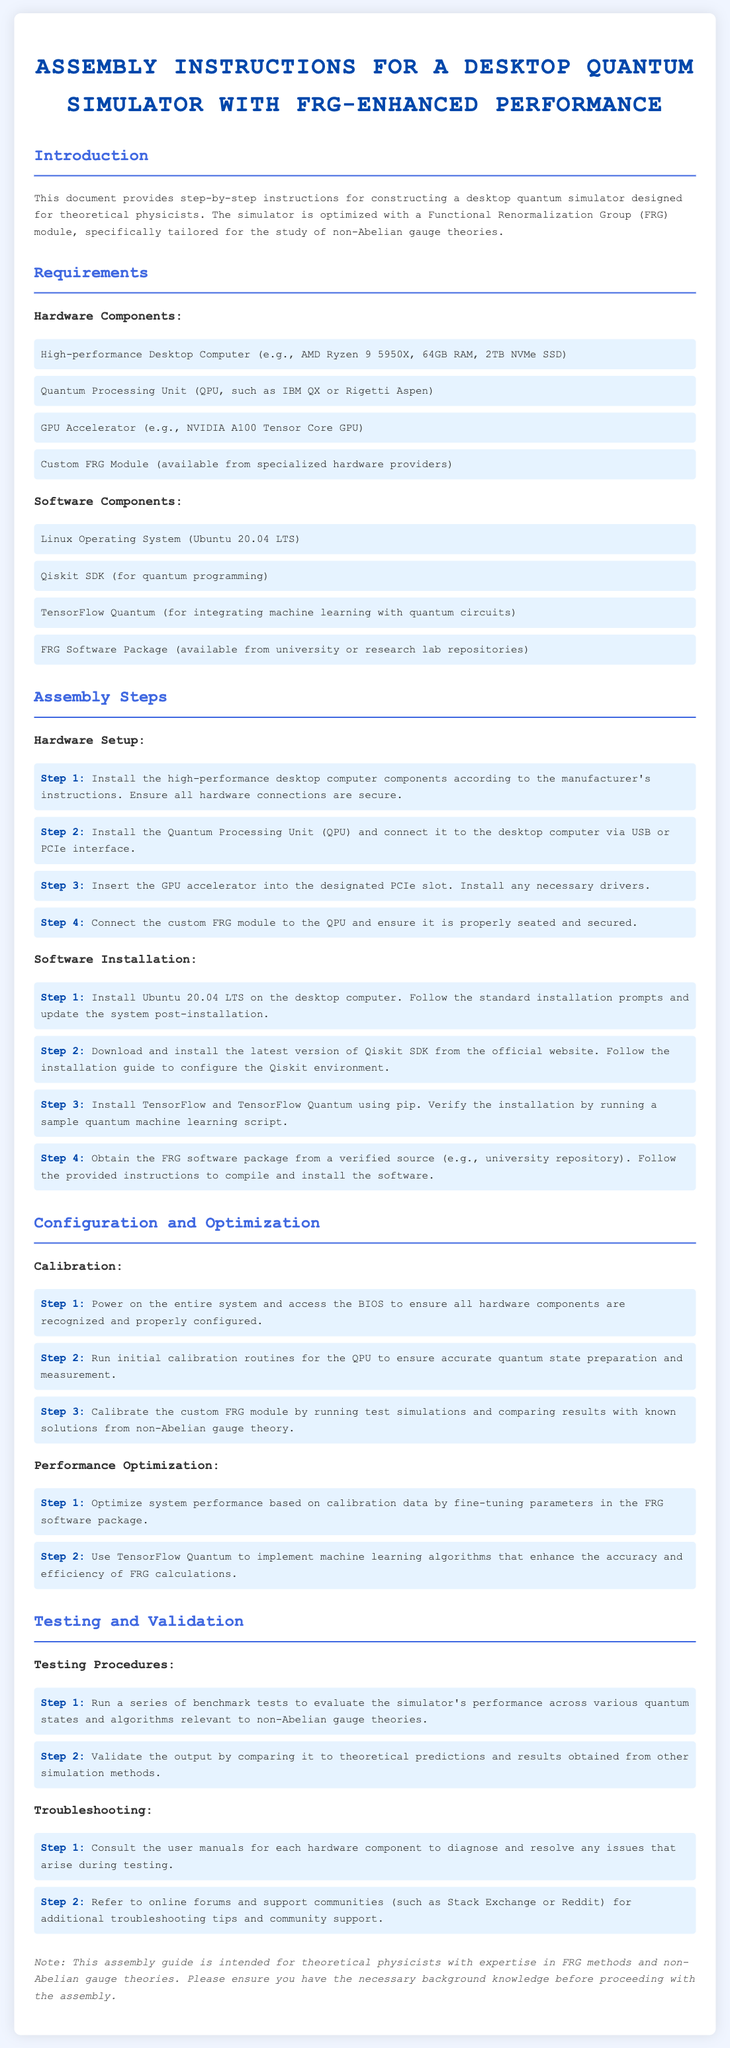What type of computer is required? The document specifies a high-performance desktop computer is needed, such as AMD Ryzen 9 5950X.
Answer: High-performance Desktop Computer What operating system should be installed? The software section mentions the installation of a Linux operating system, specifically Ubuntu 20.04 LTS.
Answer: Ubuntu 20.04 LTS What module needs to be integrated for performance enhancement? The assembly instructions highlight the inclusion of a custom FRG module to enhance performance.
Answer: FRG Module How many steps are there in the hardware setup? There are four steps listed under the hardware setup in the assembly instructions.
Answer: Four What is the first step in the software installation? The software installation section begins with installing Ubuntu 20.04 LTS on the desktop computer.
Answer: Install Ubuntu 20.04 LTS Which accelerator is mentioned for optimal performance? The document lists an NVIDIA A100 Tensor Core GPU as a required component.
Answer: NVIDIA A100 Tensor Core GPU What is the purpose of the calibration step? Calibration is intended to ensure accurate quantum state preparation and measurement in the system.
Answer: Accurate quantum state preparation What should be done if there are troubleshooting issues? The assembly guide suggests consulting user manuals for diagnosing and resolving issues during testing.
Answer: Consult user manuals How can performance optimization be achieved? Performance optimization can be done by fine-tuning parameters in the FRG software package based on calibration data.
Answer: Fine-tuning parameters in FRG software package 